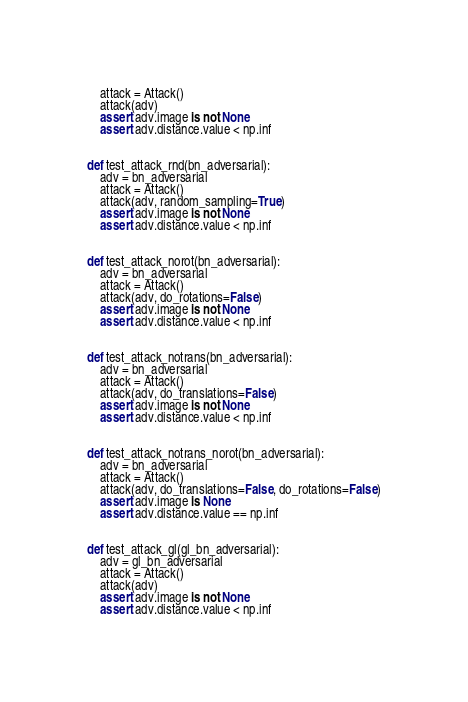Convert code to text. <code><loc_0><loc_0><loc_500><loc_500><_Python_>    attack = Attack()
    attack(adv)
    assert adv.image is not None
    assert adv.distance.value < np.inf


def test_attack_rnd(bn_adversarial):
    adv = bn_adversarial
    attack = Attack()
    attack(adv, random_sampling=True)
    assert adv.image is not None
    assert adv.distance.value < np.inf


def test_attack_norot(bn_adversarial):
    adv = bn_adversarial
    attack = Attack()
    attack(adv, do_rotations=False)
    assert adv.image is not None
    assert adv.distance.value < np.inf


def test_attack_notrans(bn_adversarial):
    adv = bn_adversarial
    attack = Attack()
    attack(adv, do_translations=False)
    assert adv.image is not None
    assert adv.distance.value < np.inf


def test_attack_notrans_norot(bn_adversarial):
    adv = bn_adversarial
    attack = Attack()
    attack(adv, do_translations=False, do_rotations=False)
    assert adv.image is None
    assert adv.distance.value == np.inf


def test_attack_gl(gl_bn_adversarial):
    adv = gl_bn_adversarial
    attack = Attack()
    attack(adv)
    assert adv.image is not None
    assert adv.distance.value < np.inf
</code> 